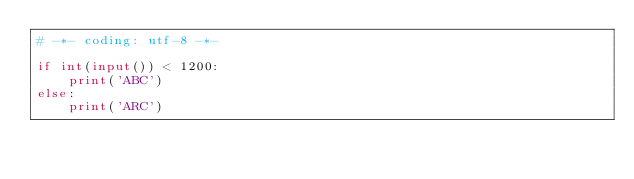Convert code to text. <code><loc_0><loc_0><loc_500><loc_500><_Python_># -*- coding: utf-8 -*-

if int(input()) < 1200:
    print('ABC')
else:
    print('ARC')</code> 